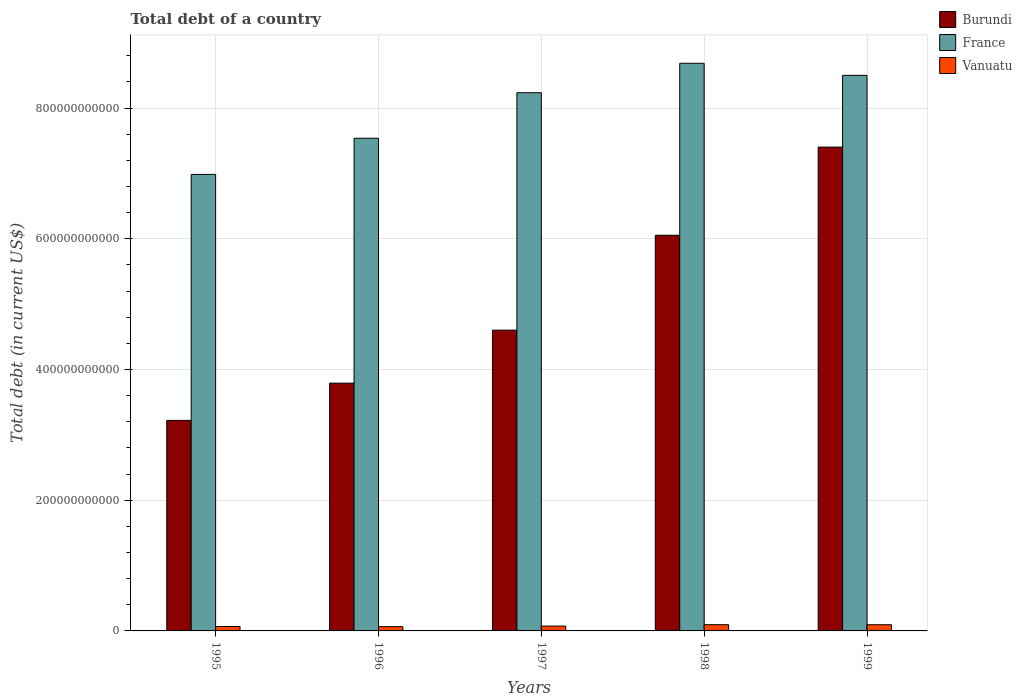Are the number of bars per tick equal to the number of legend labels?
Your answer should be very brief. Yes. How many bars are there on the 1st tick from the right?
Offer a terse response. 3. What is the label of the 2nd group of bars from the left?
Your answer should be compact. 1996. In how many cases, is the number of bars for a given year not equal to the number of legend labels?
Give a very brief answer. 0. What is the debt in Vanuatu in 1999?
Ensure brevity in your answer.  9.44e+09. Across all years, what is the maximum debt in Burundi?
Make the answer very short. 7.40e+11. Across all years, what is the minimum debt in France?
Keep it short and to the point. 6.99e+11. In which year was the debt in France maximum?
Your response must be concise. 1998. What is the total debt in France in the graph?
Offer a very short reply. 3.99e+12. What is the difference between the debt in Burundi in 1995 and that in 1998?
Give a very brief answer. -2.83e+11. What is the difference between the debt in Burundi in 1999 and the debt in France in 1995?
Offer a very short reply. 4.18e+1. What is the average debt in France per year?
Ensure brevity in your answer.  7.99e+11. In the year 1997, what is the difference between the debt in Burundi and debt in France?
Keep it short and to the point. -3.63e+11. What is the ratio of the debt in Vanuatu in 1997 to that in 1998?
Provide a succinct answer. 0.78. Is the difference between the debt in Burundi in 1998 and 1999 greater than the difference between the debt in France in 1998 and 1999?
Provide a short and direct response. No. What is the difference between the highest and the second highest debt in Vanuatu?
Offer a terse response. 5.50e+07. What is the difference between the highest and the lowest debt in France?
Your answer should be compact. 1.70e+11. What does the 3rd bar from the left in 1997 represents?
Your answer should be very brief. Vanuatu. What does the 3rd bar from the right in 1995 represents?
Provide a succinct answer. Burundi. Is it the case that in every year, the sum of the debt in Burundi and debt in France is greater than the debt in Vanuatu?
Give a very brief answer. Yes. What is the difference between two consecutive major ticks on the Y-axis?
Offer a very short reply. 2.00e+11. Are the values on the major ticks of Y-axis written in scientific E-notation?
Make the answer very short. No. Where does the legend appear in the graph?
Keep it short and to the point. Top right. How many legend labels are there?
Make the answer very short. 3. What is the title of the graph?
Provide a succinct answer. Total debt of a country. Does "Other small states" appear as one of the legend labels in the graph?
Ensure brevity in your answer.  No. What is the label or title of the Y-axis?
Keep it short and to the point. Total debt (in current US$). What is the Total debt (in current US$) in Burundi in 1995?
Offer a very short reply. 3.22e+11. What is the Total debt (in current US$) of France in 1995?
Your response must be concise. 6.99e+11. What is the Total debt (in current US$) of Vanuatu in 1995?
Provide a short and direct response. 6.76e+09. What is the Total debt (in current US$) of Burundi in 1996?
Your response must be concise. 3.79e+11. What is the Total debt (in current US$) of France in 1996?
Your response must be concise. 7.54e+11. What is the Total debt (in current US$) of Vanuatu in 1996?
Your answer should be compact. 6.52e+09. What is the Total debt (in current US$) in Burundi in 1997?
Keep it short and to the point. 4.60e+11. What is the Total debt (in current US$) of France in 1997?
Make the answer very short. 8.24e+11. What is the Total debt (in current US$) in Vanuatu in 1997?
Your answer should be very brief. 7.38e+09. What is the Total debt (in current US$) of Burundi in 1998?
Your response must be concise. 6.05e+11. What is the Total debt (in current US$) in France in 1998?
Keep it short and to the point. 8.69e+11. What is the Total debt (in current US$) of Vanuatu in 1998?
Provide a short and direct response. 9.50e+09. What is the Total debt (in current US$) of Burundi in 1999?
Provide a short and direct response. 7.40e+11. What is the Total debt (in current US$) of France in 1999?
Provide a succinct answer. 8.50e+11. What is the Total debt (in current US$) of Vanuatu in 1999?
Provide a short and direct response. 9.44e+09. Across all years, what is the maximum Total debt (in current US$) in Burundi?
Provide a short and direct response. 7.40e+11. Across all years, what is the maximum Total debt (in current US$) in France?
Provide a short and direct response. 8.69e+11. Across all years, what is the maximum Total debt (in current US$) in Vanuatu?
Offer a very short reply. 9.50e+09. Across all years, what is the minimum Total debt (in current US$) of Burundi?
Your answer should be compact. 3.22e+11. Across all years, what is the minimum Total debt (in current US$) in France?
Your response must be concise. 6.99e+11. Across all years, what is the minimum Total debt (in current US$) of Vanuatu?
Provide a succinct answer. 6.52e+09. What is the total Total debt (in current US$) in Burundi in the graph?
Keep it short and to the point. 2.51e+12. What is the total Total debt (in current US$) in France in the graph?
Provide a short and direct response. 3.99e+12. What is the total Total debt (in current US$) of Vanuatu in the graph?
Your answer should be very brief. 3.96e+1. What is the difference between the Total debt (in current US$) of Burundi in 1995 and that in 1996?
Your response must be concise. -5.70e+1. What is the difference between the Total debt (in current US$) of France in 1995 and that in 1996?
Offer a very short reply. -5.53e+1. What is the difference between the Total debt (in current US$) of Vanuatu in 1995 and that in 1996?
Ensure brevity in your answer.  2.37e+08. What is the difference between the Total debt (in current US$) of Burundi in 1995 and that in 1997?
Your answer should be very brief. -1.38e+11. What is the difference between the Total debt (in current US$) in France in 1995 and that in 1997?
Your response must be concise. -1.25e+11. What is the difference between the Total debt (in current US$) in Vanuatu in 1995 and that in 1997?
Your answer should be very brief. -6.21e+08. What is the difference between the Total debt (in current US$) of Burundi in 1995 and that in 1998?
Make the answer very short. -2.83e+11. What is the difference between the Total debt (in current US$) of France in 1995 and that in 1998?
Your answer should be compact. -1.70e+11. What is the difference between the Total debt (in current US$) in Vanuatu in 1995 and that in 1998?
Your response must be concise. -2.74e+09. What is the difference between the Total debt (in current US$) of Burundi in 1995 and that in 1999?
Make the answer very short. -4.18e+11. What is the difference between the Total debt (in current US$) in France in 1995 and that in 1999?
Offer a very short reply. -1.52e+11. What is the difference between the Total debt (in current US$) of Vanuatu in 1995 and that in 1999?
Your response must be concise. -2.68e+09. What is the difference between the Total debt (in current US$) in Burundi in 1996 and that in 1997?
Offer a terse response. -8.11e+1. What is the difference between the Total debt (in current US$) in France in 1996 and that in 1997?
Offer a very short reply. -6.97e+1. What is the difference between the Total debt (in current US$) of Vanuatu in 1996 and that in 1997?
Your answer should be very brief. -8.58e+08. What is the difference between the Total debt (in current US$) of Burundi in 1996 and that in 1998?
Give a very brief answer. -2.26e+11. What is the difference between the Total debt (in current US$) in France in 1996 and that in 1998?
Offer a terse response. -1.15e+11. What is the difference between the Total debt (in current US$) of Vanuatu in 1996 and that in 1998?
Offer a terse response. -2.98e+09. What is the difference between the Total debt (in current US$) in Burundi in 1996 and that in 1999?
Make the answer very short. -3.61e+11. What is the difference between the Total debt (in current US$) of France in 1996 and that in 1999?
Offer a very short reply. -9.63e+1. What is the difference between the Total debt (in current US$) in Vanuatu in 1996 and that in 1999?
Provide a succinct answer. -2.92e+09. What is the difference between the Total debt (in current US$) of Burundi in 1997 and that in 1998?
Make the answer very short. -1.45e+11. What is the difference between the Total debt (in current US$) of France in 1997 and that in 1998?
Offer a very short reply. -4.51e+1. What is the difference between the Total debt (in current US$) of Vanuatu in 1997 and that in 1998?
Ensure brevity in your answer.  -2.12e+09. What is the difference between the Total debt (in current US$) in Burundi in 1997 and that in 1999?
Provide a short and direct response. -2.80e+11. What is the difference between the Total debt (in current US$) in France in 1997 and that in 1999?
Your response must be concise. -2.66e+1. What is the difference between the Total debt (in current US$) of Vanuatu in 1997 and that in 1999?
Offer a very short reply. -2.06e+09. What is the difference between the Total debt (in current US$) in Burundi in 1998 and that in 1999?
Offer a terse response. -1.35e+11. What is the difference between the Total debt (in current US$) of France in 1998 and that in 1999?
Make the answer very short. 1.85e+1. What is the difference between the Total debt (in current US$) of Vanuatu in 1998 and that in 1999?
Offer a very short reply. 5.50e+07. What is the difference between the Total debt (in current US$) in Burundi in 1995 and the Total debt (in current US$) in France in 1996?
Keep it short and to the point. -4.32e+11. What is the difference between the Total debt (in current US$) in Burundi in 1995 and the Total debt (in current US$) in Vanuatu in 1996?
Give a very brief answer. 3.16e+11. What is the difference between the Total debt (in current US$) in France in 1995 and the Total debt (in current US$) in Vanuatu in 1996?
Offer a terse response. 6.92e+11. What is the difference between the Total debt (in current US$) of Burundi in 1995 and the Total debt (in current US$) of France in 1997?
Keep it short and to the point. -5.01e+11. What is the difference between the Total debt (in current US$) in Burundi in 1995 and the Total debt (in current US$) in Vanuatu in 1997?
Provide a succinct answer. 3.15e+11. What is the difference between the Total debt (in current US$) in France in 1995 and the Total debt (in current US$) in Vanuatu in 1997?
Offer a very short reply. 6.91e+11. What is the difference between the Total debt (in current US$) of Burundi in 1995 and the Total debt (in current US$) of France in 1998?
Ensure brevity in your answer.  -5.46e+11. What is the difference between the Total debt (in current US$) in Burundi in 1995 and the Total debt (in current US$) in Vanuatu in 1998?
Keep it short and to the point. 3.13e+11. What is the difference between the Total debt (in current US$) of France in 1995 and the Total debt (in current US$) of Vanuatu in 1998?
Your answer should be compact. 6.89e+11. What is the difference between the Total debt (in current US$) in Burundi in 1995 and the Total debt (in current US$) in France in 1999?
Offer a very short reply. -5.28e+11. What is the difference between the Total debt (in current US$) in Burundi in 1995 and the Total debt (in current US$) in Vanuatu in 1999?
Offer a very short reply. 3.13e+11. What is the difference between the Total debt (in current US$) in France in 1995 and the Total debt (in current US$) in Vanuatu in 1999?
Give a very brief answer. 6.89e+11. What is the difference between the Total debt (in current US$) of Burundi in 1996 and the Total debt (in current US$) of France in 1997?
Your answer should be very brief. -4.44e+11. What is the difference between the Total debt (in current US$) in Burundi in 1996 and the Total debt (in current US$) in Vanuatu in 1997?
Offer a terse response. 3.72e+11. What is the difference between the Total debt (in current US$) of France in 1996 and the Total debt (in current US$) of Vanuatu in 1997?
Your response must be concise. 7.46e+11. What is the difference between the Total debt (in current US$) of Burundi in 1996 and the Total debt (in current US$) of France in 1998?
Provide a short and direct response. -4.89e+11. What is the difference between the Total debt (in current US$) of Burundi in 1996 and the Total debt (in current US$) of Vanuatu in 1998?
Your answer should be compact. 3.70e+11. What is the difference between the Total debt (in current US$) of France in 1996 and the Total debt (in current US$) of Vanuatu in 1998?
Offer a terse response. 7.44e+11. What is the difference between the Total debt (in current US$) in Burundi in 1996 and the Total debt (in current US$) in France in 1999?
Your answer should be compact. -4.71e+11. What is the difference between the Total debt (in current US$) in Burundi in 1996 and the Total debt (in current US$) in Vanuatu in 1999?
Your response must be concise. 3.70e+11. What is the difference between the Total debt (in current US$) in France in 1996 and the Total debt (in current US$) in Vanuatu in 1999?
Give a very brief answer. 7.44e+11. What is the difference between the Total debt (in current US$) in Burundi in 1997 and the Total debt (in current US$) in France in 1998?
Offer a terse response. -4.08e+11. What is the difference between the Total debt (in current US$) of Burundi in 1997 and the Total debt (in current US$) of Vanuatu in 1998?
Your answer should be compact. 4.51e+11. What is the difference between the Total debt (in current US$) of France in 1997 and the Total debt (in current US$) of Vanuatu in 1998?
Offer a very short reply. 8.14e+11. What is the difference between the Total debt (in current US$) in Burundi in 1997 and the Total debt (in current US$) in France in 1999?
Keep it short and to the point. -3.90e+11. What is the difference between the Total debt (in current US$) in Burundi in 1997 and the Total debt (in current US$) in Vanuatu in 1999?
Make the answer very short. 4.51e+11. What is the difference between the Total debt (in current US$) in France in 1997 and the Total debt (in current US$) in Vanuatu in 1999?
Your answer should be very brief. 8.14e+11. What is the difference between the Total debt (in current US$) in Burundi in 1998 and the Total debt (in current US$) in France in 1999?
Provide a short and direct response. -2.45e+11. What is the difference between the Total debt (in current US$) in Burundi in 1998 and the Total debt (in current US$) in Vanuatu in 1999?
Offer a terse response. 5.96e+11. What is the difference between the Total debt (in current US$) of France in 1998 and the Total debt (in current US$) of Vanuatu in 1999?
Keep it short and to the point. 8.59e+11. What is the average Total debt (in current US$) in Burundi per year?
Give a very brief answer. 5.01e+11. What is the average Total debt (in current US$) of France per year?
Offer a very short reply. 7.99e+11. What is the average Total debt (in current US$) of Vanuatu per year?
Provide a succinct answer. 7.92e+09. In the year 1995, what is the difference between the Total debt (in current US$) in Burundi and Total debt (in current US$) in France?
Make the answer very short. -3.76e+11. In the year 1995, what is the difference between the Total debt (in current US$) in Burundi and Total debt (in current US$) in Vanuatu?
Provide a short and direct response. 3.15e+11. In the year 1995, what is the difference between the Total debt (in current US$) of France and Total debt (in current US$) of Vanuatu?
Your answer should be very brief. 6.92e+11. In the year 1996, what is the difference between the Total debt (in current US$) in Burundi and Total debt (in current US$) in France?
Give a very brief answer. -3.75e+11. In the year 1996, what is the difference between the Total debt (in current US$) in Burundi and Total debt (in current US$) in Vanuatu?
Make the answer very short. 3.73e+11. In the year 1996, what is the difference between the Total debt (in current US$) in France and Total debt (in current US$) in Vanuatu?
Offer a terse response. 7.47e+11. In the year 1997, what is the difference between the Total debt (in current US$) of Burundi and Total debt (in current US$) of France?
Give a very brief answer. -3.63e+11. In the year 1997, what is the difference between the Total debt (in current US$) in Burundi and Total debt (in current US$) in Vanuatu?
Keep it short and to the point. 4.53e+11. In the year 1997, what is the difference between the Total debt (in current US$) of France and Total debt (in current US$) of Vanuatu?
Provide a short and direct response. 8.16e+11. In the year 1998, what is the difference between the Total debt (in current US$) of Burundi and Total debt (in current US$) of France?
Your answer should be very brief. -2.63e+11. In the year 1998, what is the difference between the Total debt (in current US$) of Burundi and Total debt (in current US$) of Vanuatu?
Give a very brief answer. 5.96e+11. In the year 1998, what is the difference between the Total debt (in current US$) of France and Total debt (in current US$) of Vanuatu?
Make the answer very short. 8.59e+11. In the year 1999, what is the difference between the Total debt (in current US$) in Burundi and Total debt (in current US$) in France?
Offer a very short reply. -1.10e+11. In the year 1999, what is the difference between the Total debt (in current US$) of Burundi and Total debt (in current US$) of Vanuatu?
Provide a succinct answer. 7.31e+11. In the year 1999, what is the difference between the Total debt (in current US$) of France and Total debt (in current US$) of Vanuatu?
Your response must be concise. 8.41e+11. What is the ratio of the Total debt (in current US$) in Burundi in 1995 to that in 1996?
Your answer should be compact. 0.85. What is the ratio of the Total debt (in current US$) in France in 1995 to that in 1996?
Offer a terse response. 0.93. What is the ratio of the Total debt (in current US$) in Vanuatu in 1995 to that in 1996?
Provide a short and direct response. 1.04. What is the ratio of the Total debt (in current US$) in Burundi in 1995 to that in 1997?
Give a very brief answer. 0.7. What is the ratio of the Total debt (in current US$) of France in 1995 to that in 1997?
Keep it short and to the point. 0.85. What is the ratio of the Total debt (in current US$) in Vanuatu in 1995 to that in 1997?
Give a very brief answer. 0.92. What is the ratio of the Total debt (in current US$) of Burundi in 1995 to that in 1998?
Your answer should be compact. 0.53. What is the ratio of the Total debt (in current US$) in France in 1995 to that in 1998?
Keep it short and to the point. 0.8. What is the ratio of the Total debt (in current US$) in Vanuatu in 1995 to that in 1998?
Provide a short and direct response. 0.71. What is the ratio of the Total debt (in current US$) in Burundi in 1995 to that in 1999?
Make the answer very short. 0.44. What is the ratio of the Total debt (in current US$) of France in 1995 to that in 1999?
Give a very brief answer. 0.82. What is the ratio of the Total debt (in current US$) in Vanuatu in 1995 to that in 1999?
Your answer should be very brief. 0.72. What is the ratio of the Total debt (in current US$) in Burundi in 1996 to that in 1997?
Your response must be concise. 0.82. What is the ratio of the Total debt (in current US$) in France in 1996 to that in 1997?
Provide a succinct answer. 0.92. What is the ratio of the Total debt (in current US$) in Vanuatu in 1996 to that in 1997?
Keep it short and to the point. 0.88. What is the ratio of the Total debt (in current US$) of Burundi in 1996 to that in 1998?
Provide a succinct answer. 0.63. What is the ratio of the Total debt (in current US$) in France in 1996 to that in 1998?
Provide a short and direct response. 0.87. What is the ratio of the Total debt (in current US$) in Vanuatu in 1996 to that in 1998?
Provide a short and direct response. 0.69. What is the ratio of the Total debt (in current US$) in Burundi in 1996 to that in 1999?
Your answer should be compact. 0.51. What is the ratio of the Total debt (in current US$) in France in 1996 to that in 1999?
Ensure brevity in your answer.  0.89. What is the ratio of the Total debt (in current US$) of Vanuatu in 1996 to that in 1999?
Your response must be concise. 0.69. What is the ratio of the Total debt (in current US$) in Burundi in 1997 to that in 1998?
Keep it short and to the point. 0.76. What is the ratio of the Total debt (in current US$) in France in 1997 to that in 1998?
Provide a succinct answer. 0.95. What is the ratio of the Total debt (in current US$) in Vanuatu in 1997 to that in 1998?
Make the answer very short. 0.78. What is the ratio of the Total debt (in current US$) of Burundi in 1997 to that in 1999?
Offer a terse response. 0.62. What is the ratio of the Total debt (in current US$) of France in 1997 to that in 1999?
Your response must be concise. 0.97. What is the ratio of the Total debt (in current US$) in Vanuatu in 1997 to that in 1999?
Your answer should be very brief. 0.78. What is the ratio of the Total debt (in current US$) of Burundi in 1998 to that in 1999?
Provide a succinct answer. 0.82. What is the ratio of the Total debt (in current US$) of France in 1998 to that in 1999?
Provide a succinct answer. 1.02. What is the ratio of the Total debt (in current US$) of Vanuatu in 1998 to that in 1999?
Offer a terse response. 1.01. What is the difference between the highest and the second highest Total debt (in current US$) of Burundi?
Ensure brevity in your answer.  1.35e+11. What is the difference between the highest and the second highest Total debt (in current US$) in France?
Your answer should be compact. 1.85e+1. What is the difference between the highest and the second highest Total debt (in current US$) in Vanuatu?
Your answer should be very brief. 5.50e+07. What is the difference between the highest and the lowest Total debt (in current US$) in Burundi?
Provide a short and direct response. 4.18e+11. What is the difference between the highest and the lowest Total debt (in current US$) of France?
Make the answer very short. 1.70e+11. What is the difference between the highest and the lowest Total debt (in current US$) of Vanuatu?
Provide a succinct answer. 2.98e+09. 